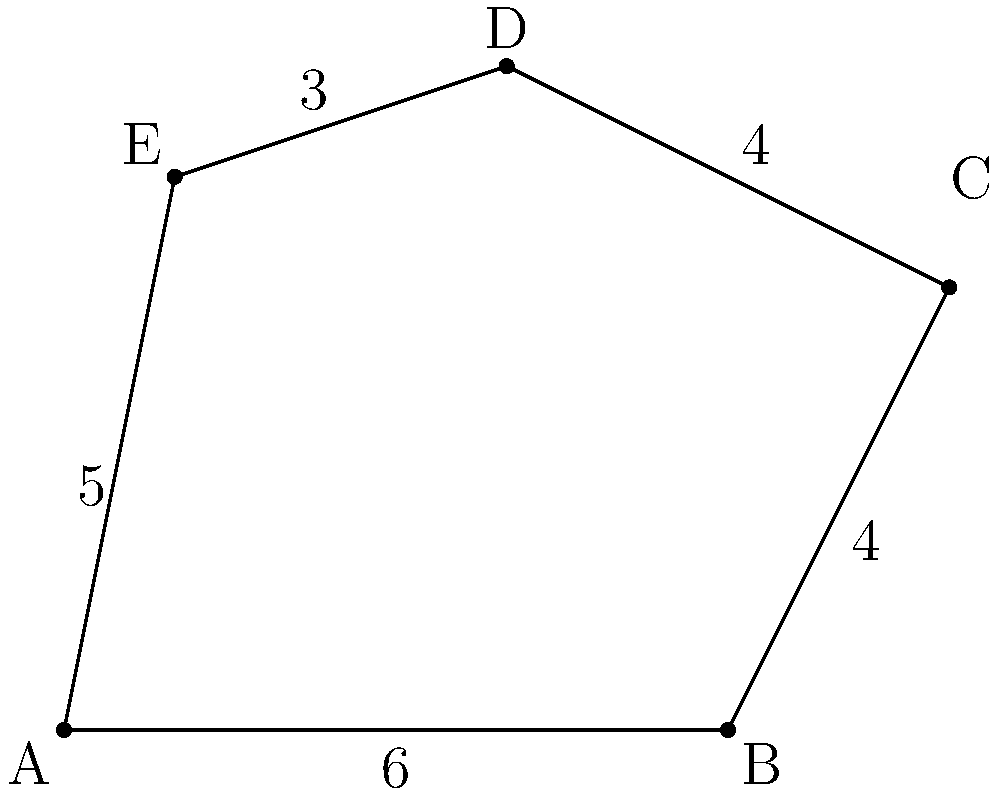In a strategic board game, a player's territory is represented by an irregular polygon on the game board. The polygon has vertices at points A(0,0), B(6,0), C(8,4), D(4,6), and E(1,5). Calculate the area of this territory using the shoelace formula (also known as the surveyor's formula). How might this calculation be useful in game design or strategy? To solve this problem, we'll use the shoelace formula and relate it to game design:

1) The shoelace formula for the area of a polygon with vertices $(x_1, y_1), (x_2, y_2), ..., (x_n, y_n)$ is:

   $$Area = \frac{1}{2}|(x_1y_2 + x_2y_3 + ... + x_ny_1) - (y_1x_2 + y_2x_3 + ... + y_nx_1)|$$

2) Let's organize our vertices:
   A(0,0), B(6,0), C(8,4), D(4,6), E(1,5)

3) Applying the formula:

   $$\begin{align}
   Area &= \frac{1}{2}|(0 \cdot 0 + 6 \cdot 4 + 8 \cdot 6 + 4 \cdot 5 + 1 \cdot 0) \\
   &\quad - (0 \cdot 6 + 0 \cdot 8 + 4 \cdot 4 + 6 \cdot 1 + 5 \cdot 0)|
   \end{align}$$

4) Simplifying:
   $$Area = \frac{1}{2}|(24 + 48 + 20) - (16 + 6)| = \frac{1}{2}|92 - 22| = \frac{1}{2} \cdot 70 = 35$$

5) Therefore, the area of the territory is 35 square units.

In game design and strategy, this calculation could be useful for:

a) Balancing gameplay: Ensuring players have equal opportunities by assigning territories of equal area.
b) Scoring mechanisms: Awarding points based on the size of controlled territories.
c) Resource allocation: Distributing resources proportionally to territory size.
d) AI decision making: Helping AI evaluate the value of different territories.
e) Map generation: Creating balanced, procedurally generated maps with territories of specific sizes.

Understanding these geometric principles can enhance game mechanics and player engagement in strategy games.
Answer: 35 square units 